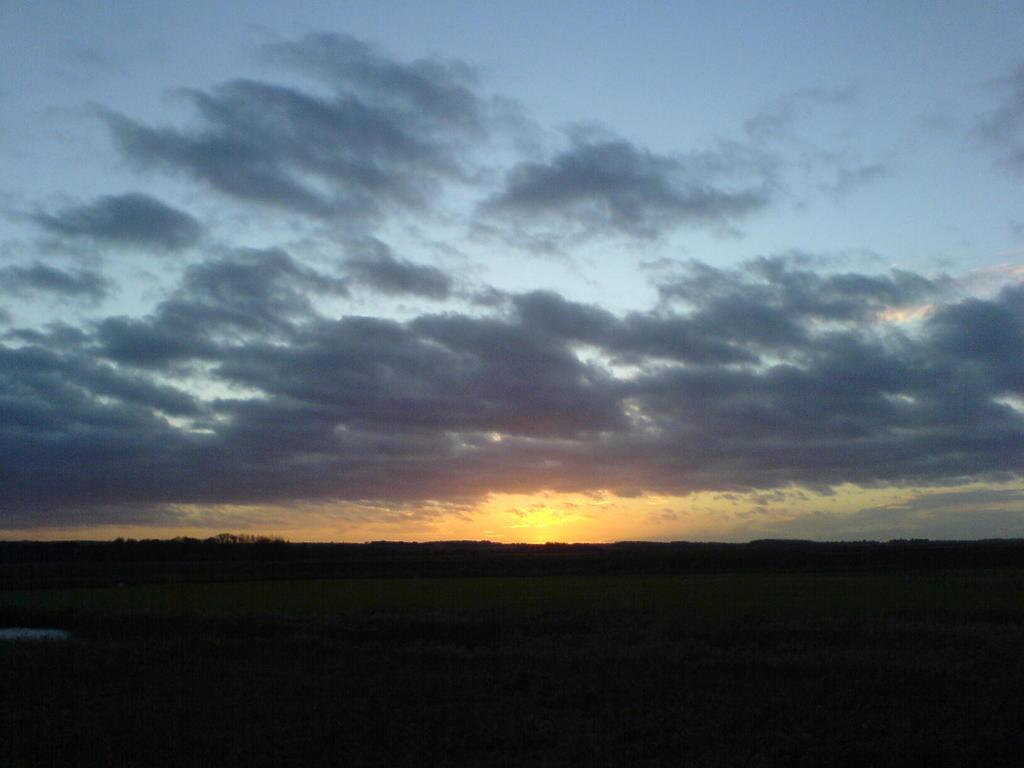What part of the natural environment is visible in the image? The sky is visible in the image. Can you describe the lighting conditions in the image? The image is a little dark. What type of joke can be seen in the image? There is no joke present in the image; it only features the sky and the lighting conditions. 